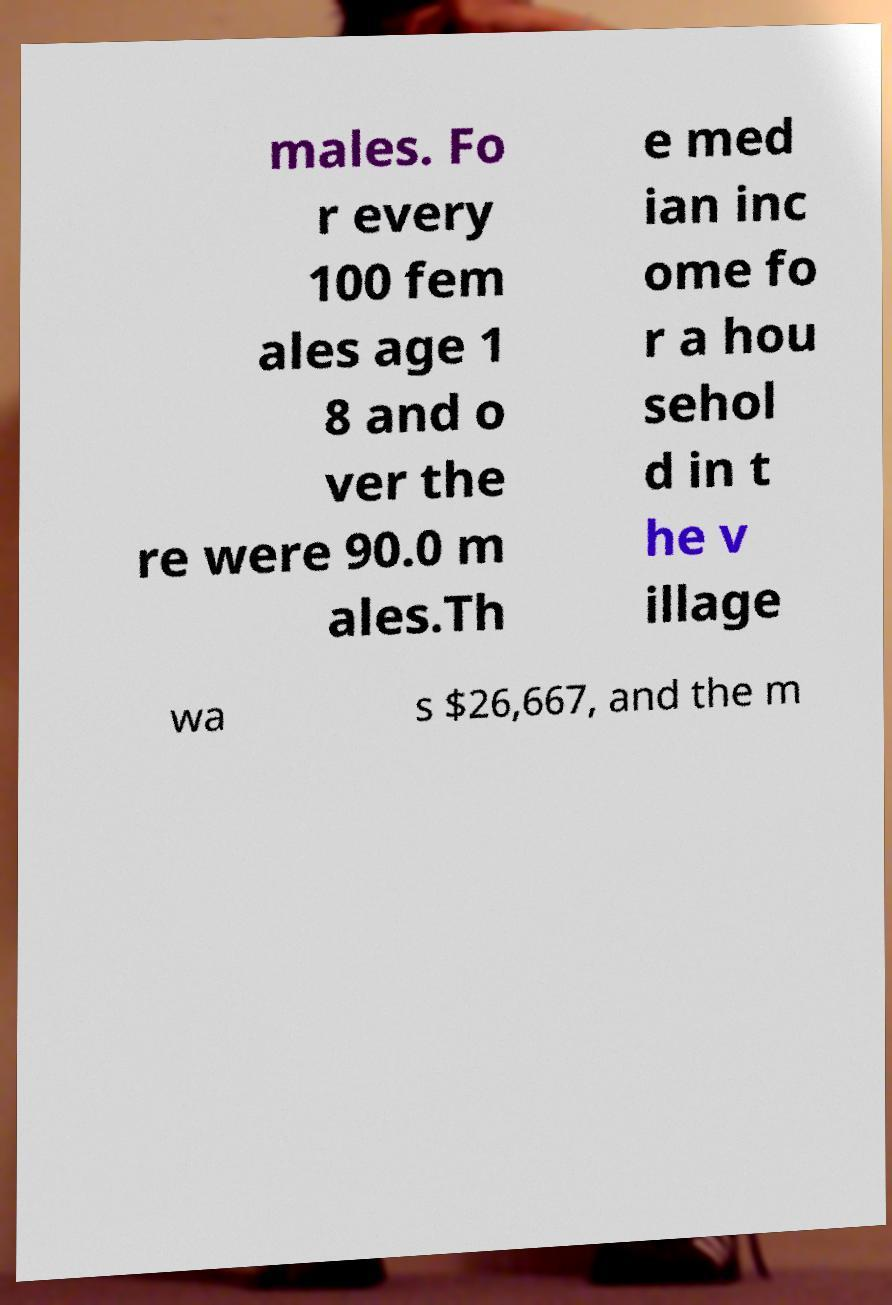I need the written content from this picture converted into text. Can you do that? males. Fo r every 100 fem ales age 1 8 and o ver the re were 90.0 m ales.Th e med ian inc ome fo r a hou sehol d in t he v illage wa s $26,667, and the m 